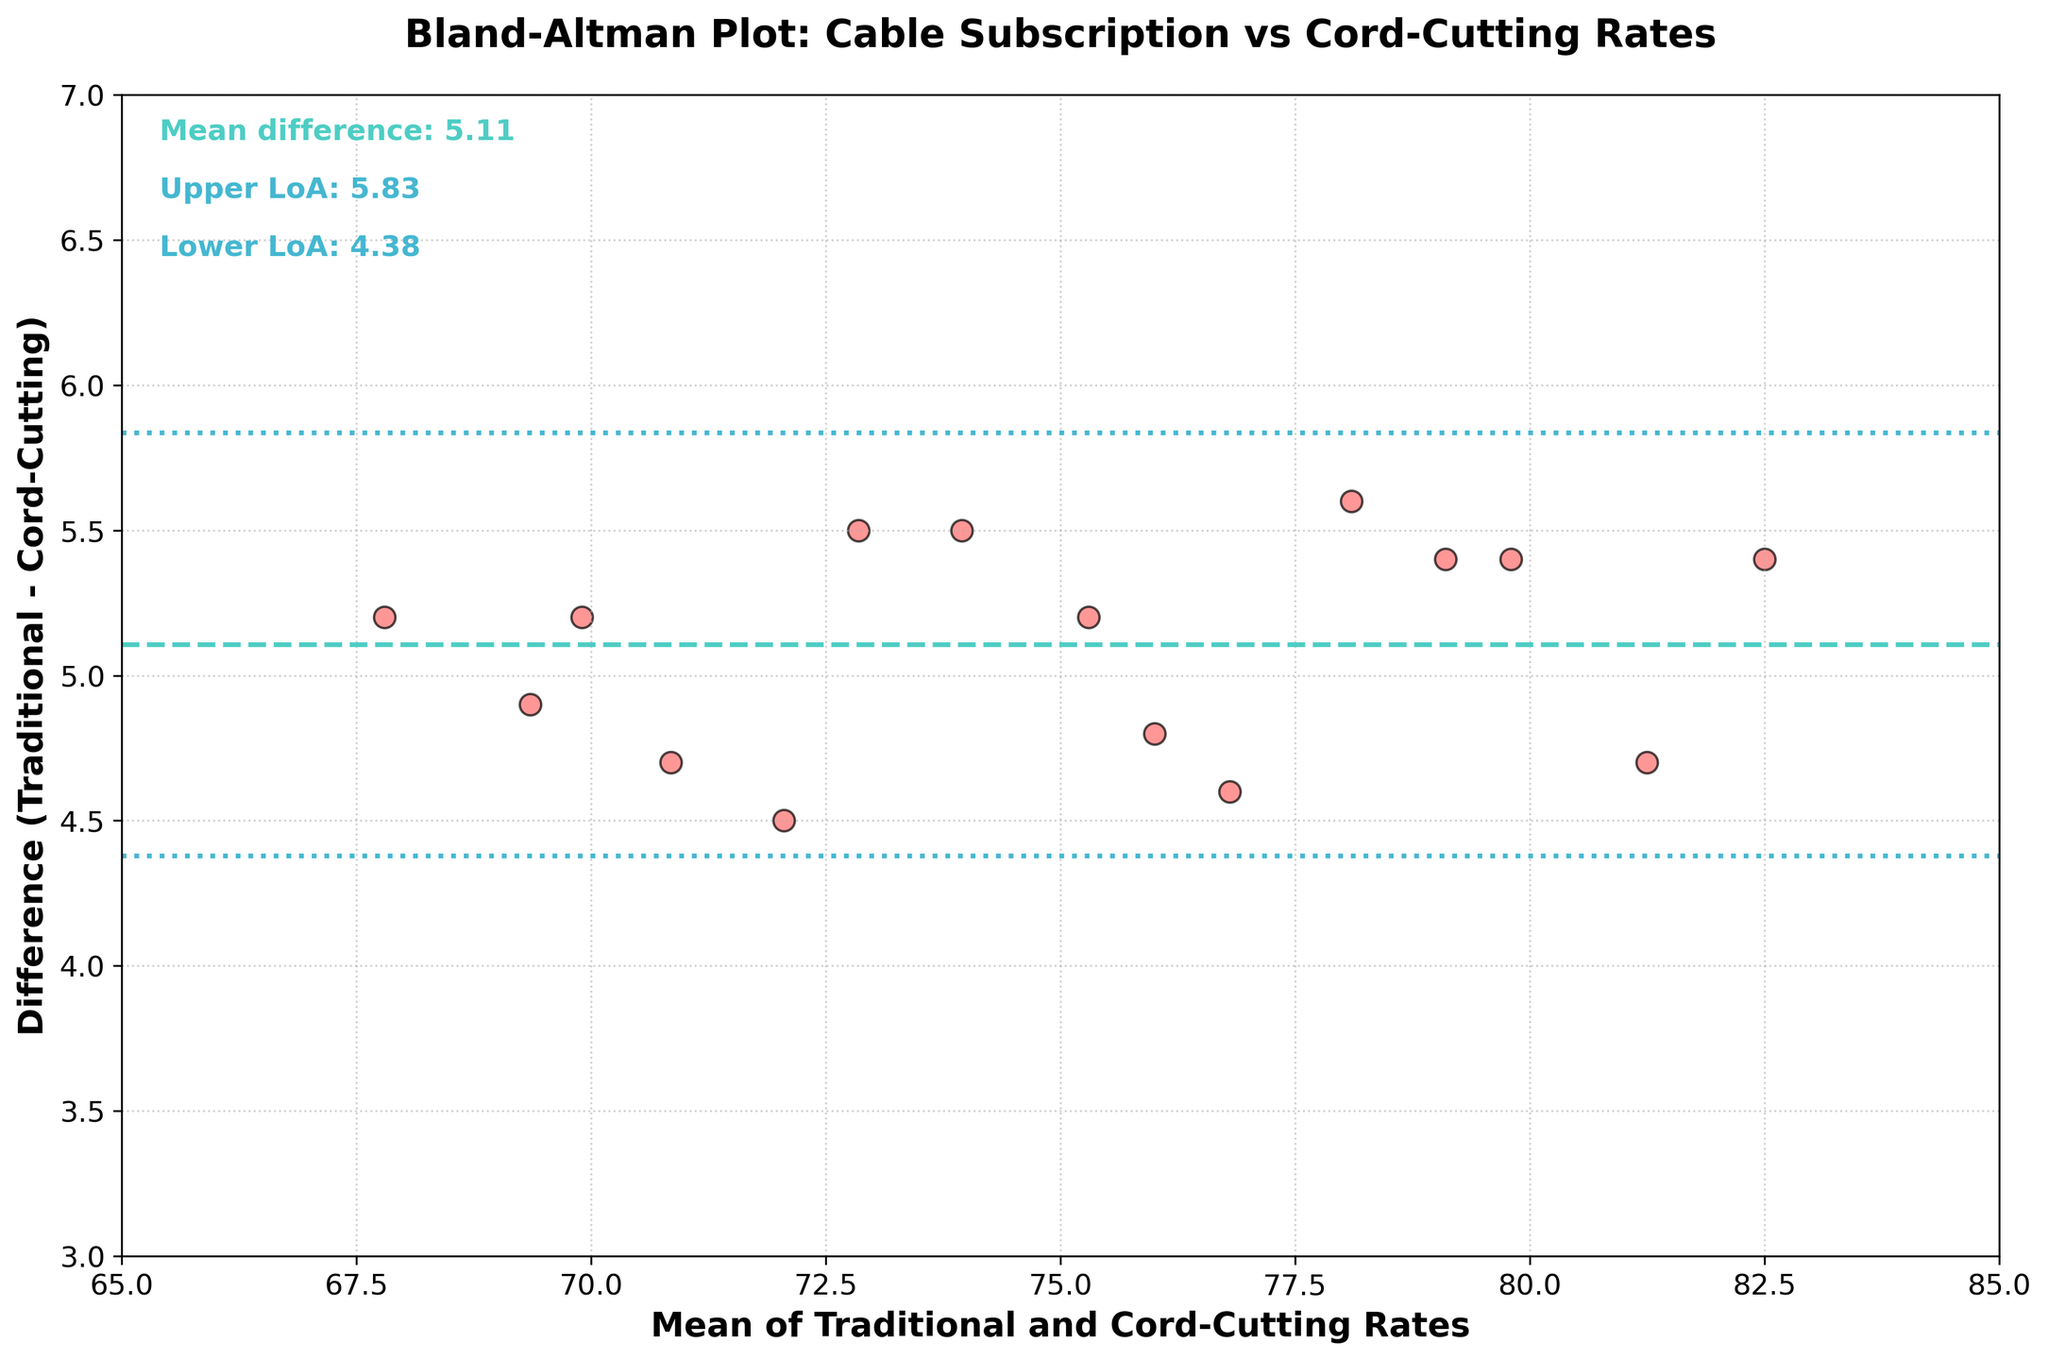What is the title of the plot? The title of a plot is typically found at the top and aims to summarize the key focus of the data being presented. In this case, it explicitly states the comparison being made.
Answer: "Bland-Altman Plot: Cable Subscription vs Cord-Cutting Rates" How many data points are plotted? To find the number of data points, simply count the number of individual points (often circles or dots) scattered on the plot area.
Answer: 15 What is the mean difference between Traditional Subscriptions and Cord-Cutting Rates? The mean difference is a horizontal line on the plot, usually accompanied by a label. The text annotation reads "Mean difference: 5.13".
Answer: 5.13 What values represent the Limits of Agreement (LoA)? The Limits of Agreement are defined by two horizontal lines on either side of the mean difference line. The text annotations indicate the upper and lower LoA values.
Answer: Upper LoA: 5.81, Lower LoA: 4.45 What is the range of values on the x-axis? The x-axis represents the mean of Traditional and Cord-Cutting Rates. The range can be derived from the axis labels or tick marks that define its lower and upper limits.
Answer: 65 to 85 Which cable provider has the largest positive difference between Traditional Subscriptions and Cord-Cutting Rates? To find the provider with the largest difference between traditional subscriptions and cord-cutting rates, look for the highest data point on the y-axis. Corresponding information from the data table shows Cox has 5.6, the highest difference value.
Answer: Cox What is the spread (range) of the differences in the plot? The spread or range is calculated by subtracting the smallest difference from the largest difference among the plotted points. From the data, the smallest difference is 4.5 and the largest is 5.6. The range is 5.6 - 4.5.
Answer: 1.1 Are there more data points above or below the mean difference line? Visually inspect the plot and count the number of points above and below the mean difference line, which is the dashed line at 5.13. Comparing the counts will provide the answer.
Answer: Below What color is used for the scatter points? The color of the scatter points can be deduced from visual inspection, noting any description in the figure's legend or the color used throughout the plot.
Answer: Red (with black edges) Do any data points lie exactly on the mean difference line? Look for any points directly on the dashed mean difference line at 5.13. If a point coincides exactly with this line, note it.
Answer: No 